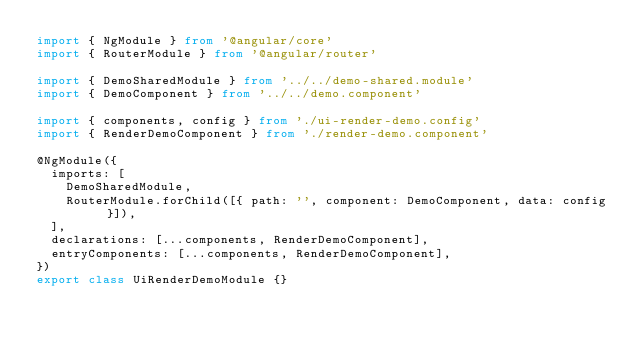<code> <loc_0><loc_0><loc_500><loc_500><_TypeScript_>import { NgModule } from '@angular/core'
import { RouterModule } from '@angular/router'

import { DemoSharedModule } from '../../demo-shared.module'
import { DemoComponent } from '../../demo.component'

import { components, config } from './ui-render-demo.config'
import { RenderDemoComponent } from './render-demo.component'

@NgModule({
  imports: [
    DemoSharedModule,
    RouterModule.forChild([{ path: '', component: DemoComponent, data: config }]),
  ],
  declarations: [...components, RenderDemoComponent],
  entryComponents: [...components, RenderDemoComponent],
})
export class UiRenderDemoModule {}
</code> 